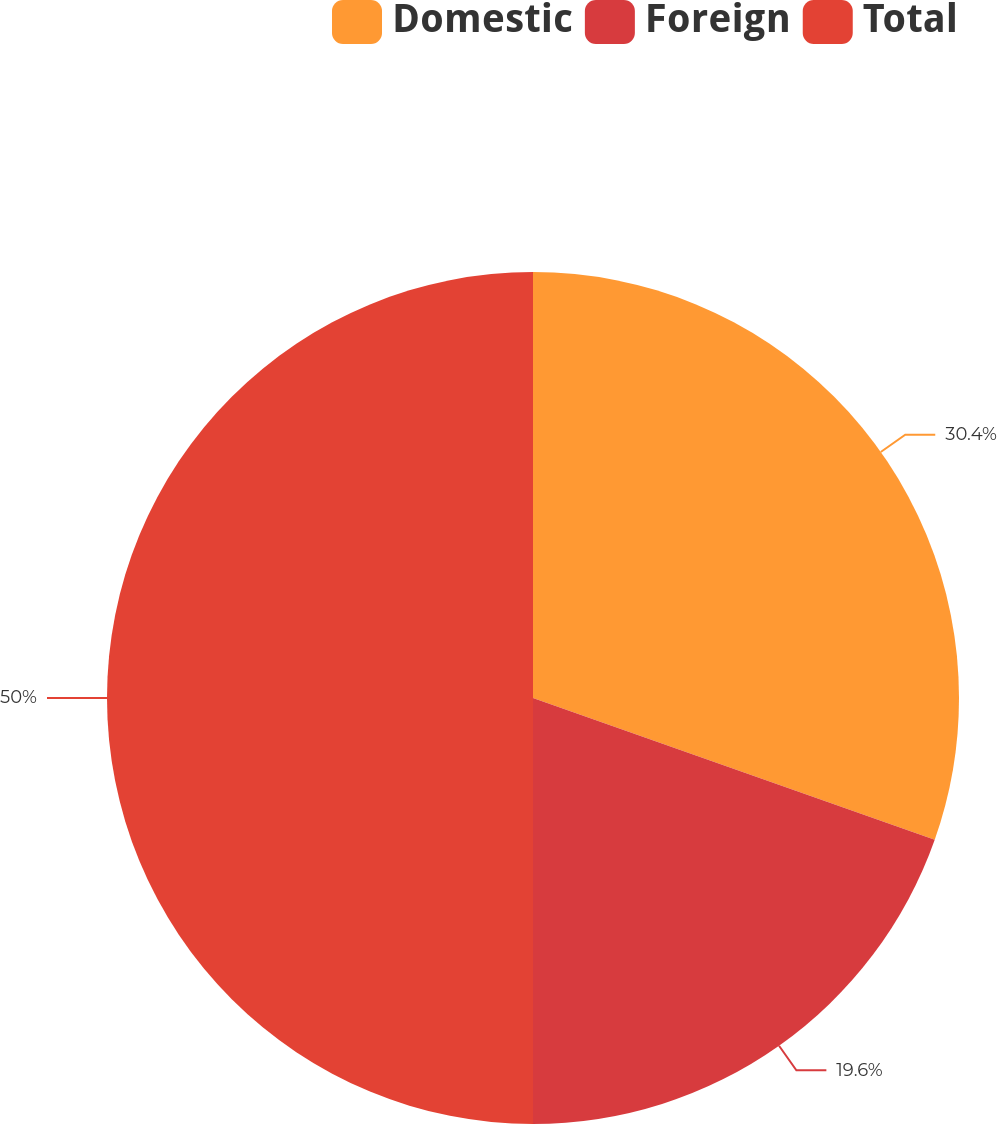<chart> <loc_0><loc_0><loc_500><loc_500><pie_chart><fcel>Domestic<fcel>Foreign<fcel>Total<nl><fcel>30.4%<fcel>19.6%<fcel>50.0%<nl></chart> 